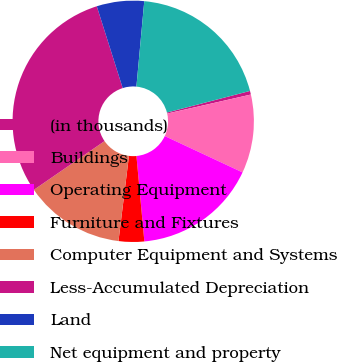Convert chart to OTSL. <chart><loc_0><loc_0><loc_500><loc_500><pie_chart><fcel>(in thousands)<fcel>Buildings<fcel>Operating Equipment<fcel>Furniture and Fixtures<fcel>Computer Equipment and Systems<fcel>Less-Accumulated Depreciation<fcel>Land<fcel>Net equipment and property<nl><fcel>0.49%<fcel>10.52%<fcel>16.57%<fcel>3.42%<fcel>13.44%<fcel>29.73%<fcel>6.34%<fcel>19.49%<nl></chart> 